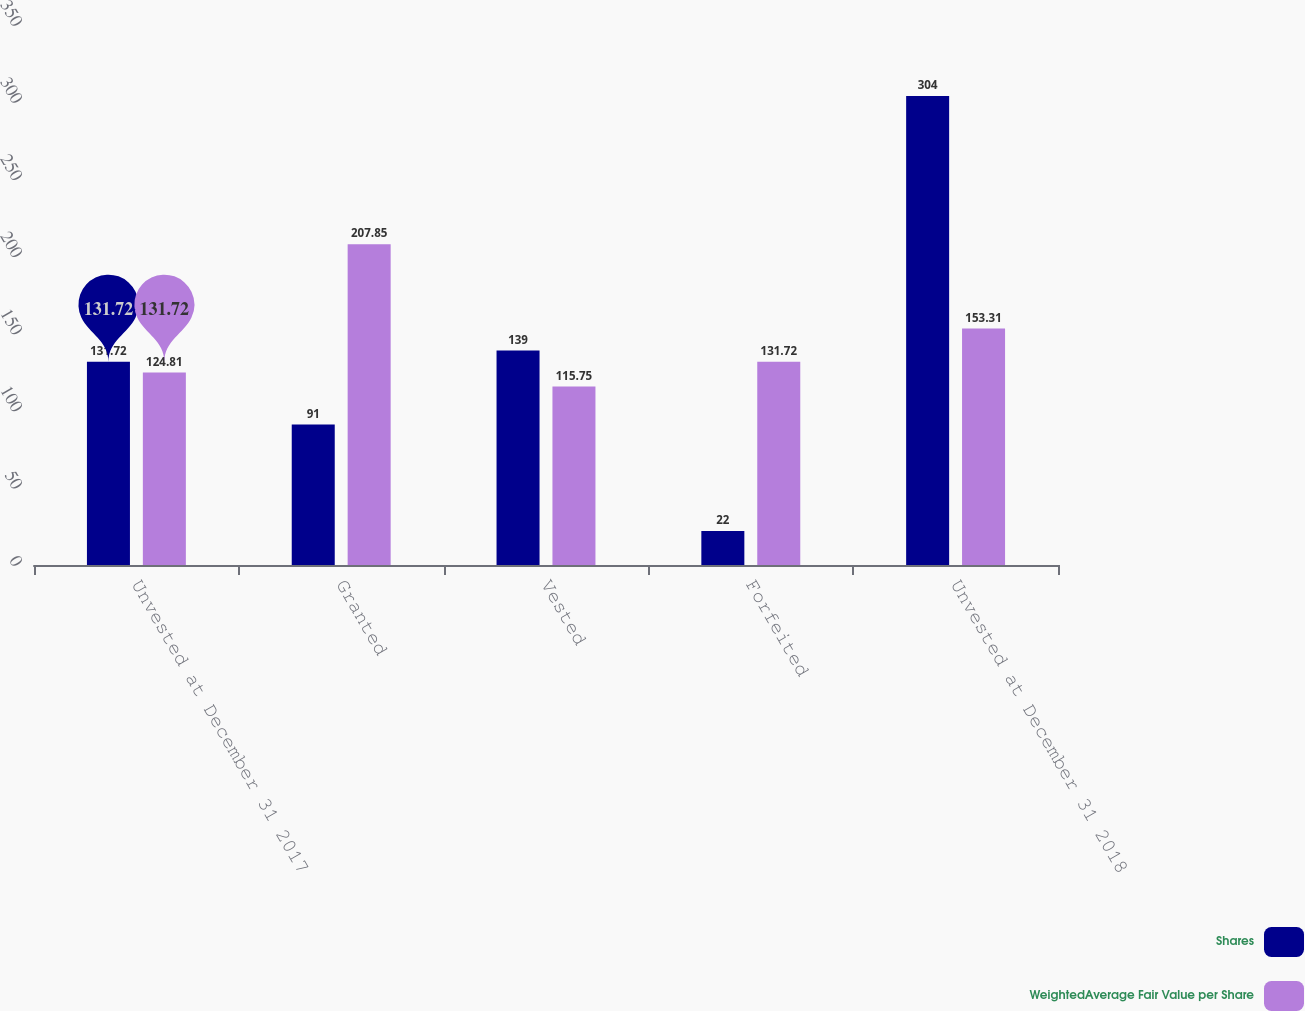Convert chart to OTSL. <chart><loc_0><loc_0><loc_500><loc_500><stacked_bar_chart><ecel><fcel>Unvested at December 31 2017<fcel>Granted<fcel>Vested<fcel>Forfeited<fcel>Unvested at December 31 2018<nl><fcel>Shares<fcel>131.72<fcel>91<fcel>139<fcel>22<fcel>304<nl><fcel>WeightedAverage Fair Value per Share<fcel>124.81<fcel>207.85<fcel>115.75<fcel>131.72<fcel>153.31<nl></chart> 